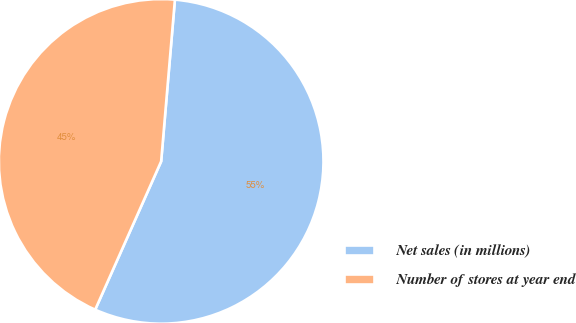Convert chart to OTSL. <chart><loc_0><loc_0><loc_500><loc_500><pie_chart><fcel>Net sales (in millions)<fcel>Number of stores at year end<nl><fcel>55.31%<fcel>44.69%<nl></chart> 